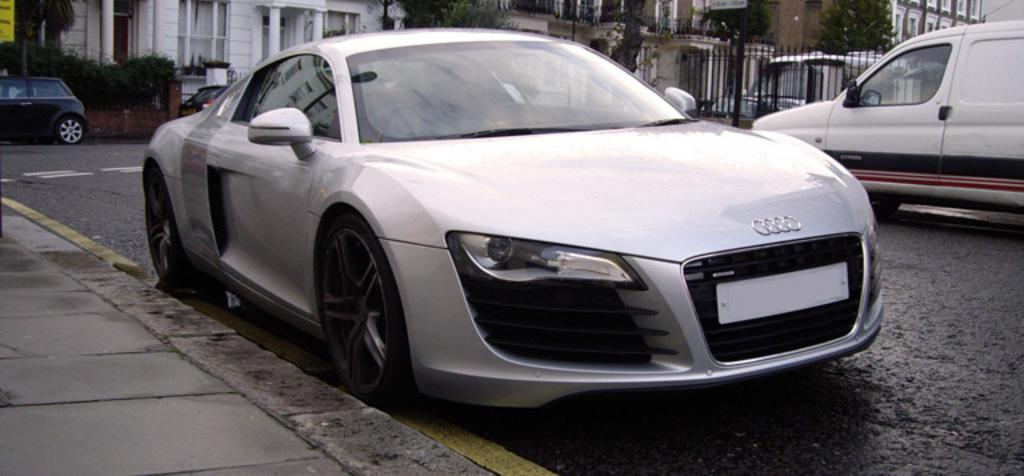What can be seen on the road in the image? There are cars on the road in the image. What type of structures are visible in the background? There are iron grills, trees, and buildings in the background of the image. What type of pie is being served on the pan in the image? There is no pan or pie present in the image. Can you describe the condition of the person's knee in the image? There are no people or knees visible in the image. 